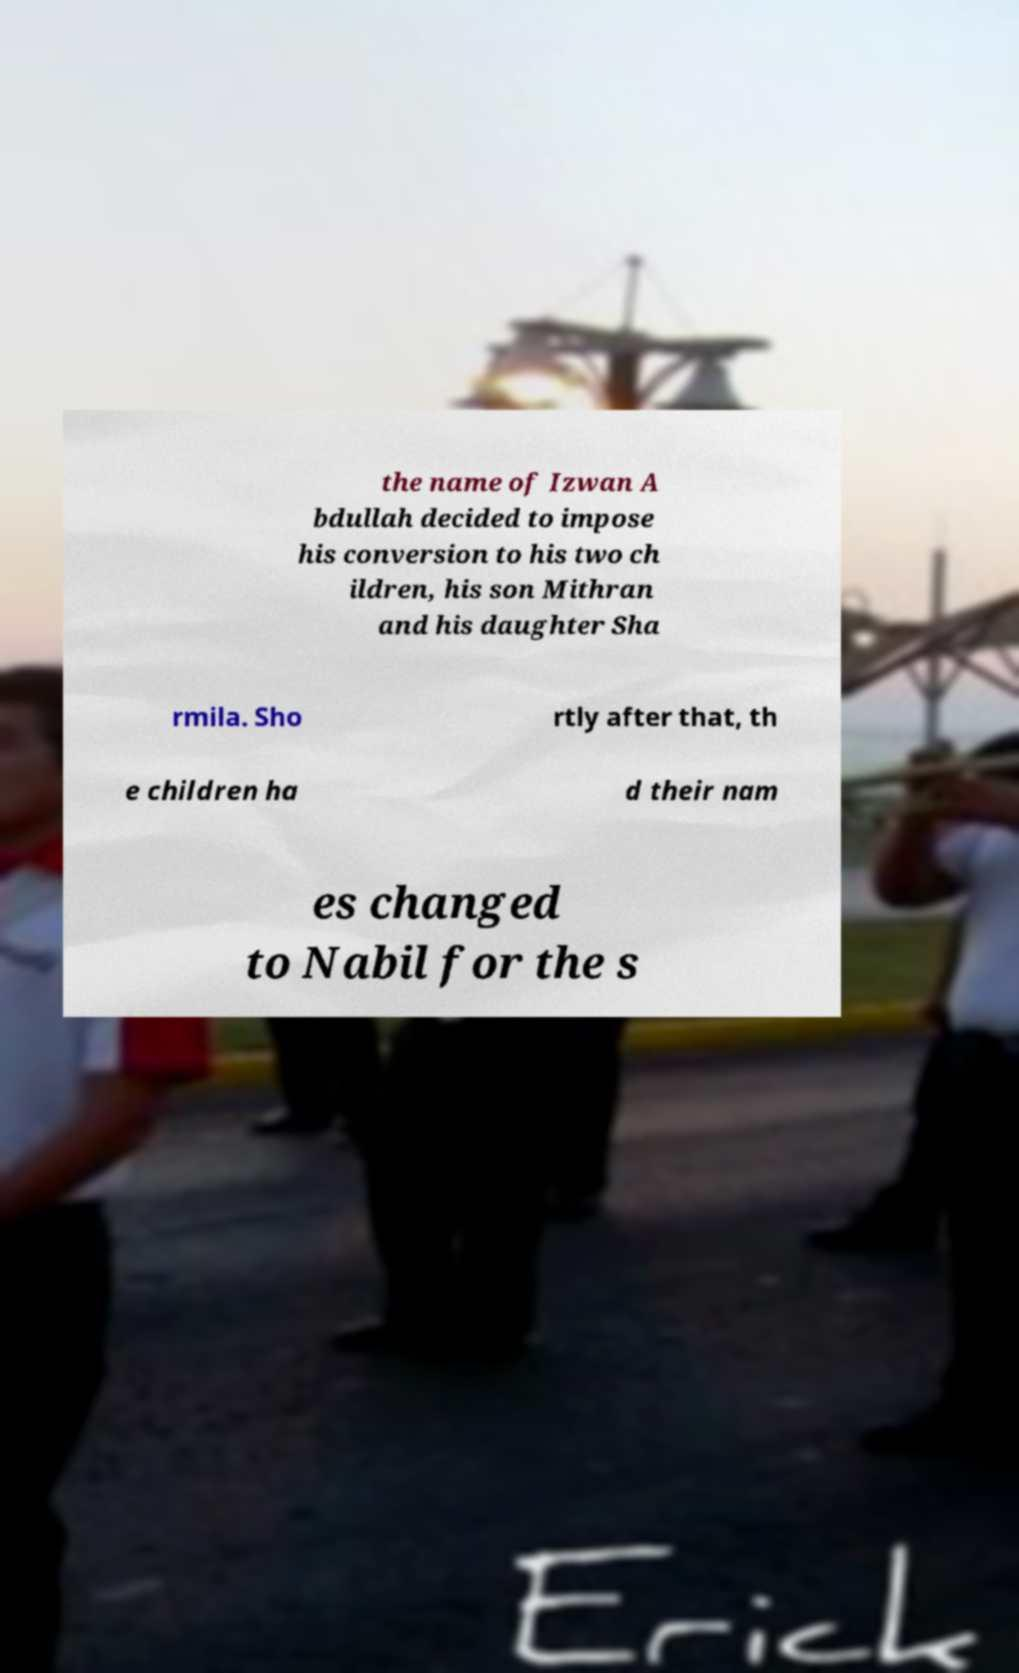What messages or text are displayed in this image? I need them in a readable, typed format. the name of Izwan A bdullah decided to impose his conversion to his two ch ildren, his son Mithran and his daughter Sha rmila. Sho rtly after that, th e children ha d their nam es changed to Nabil for the s 